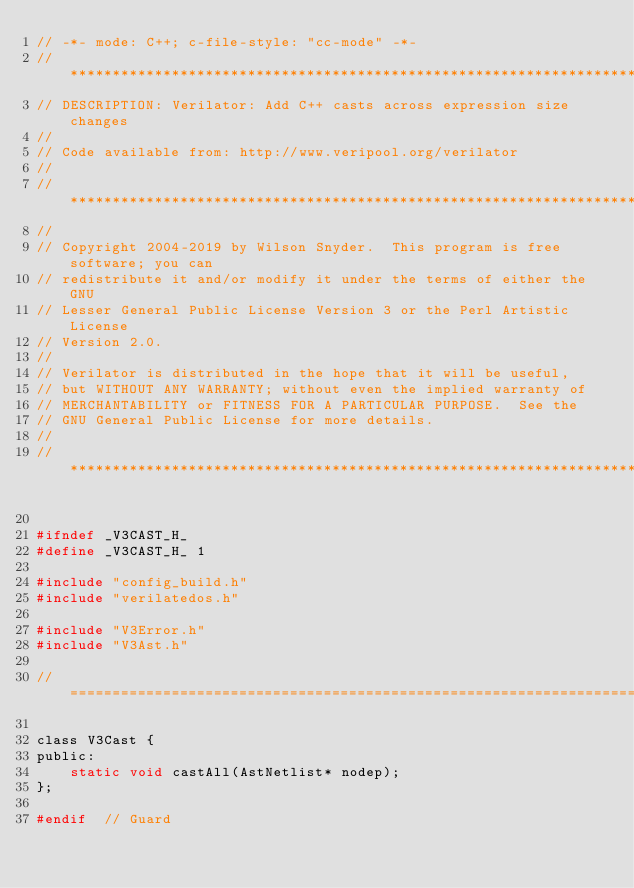Convert code to text. <code><loc_0><loc_0><loc_500><loc_500><_C_>// -*- mode: C++; c-file-style: "cc-mode" -*-
//*************************************************************************
// DESCRIPTION: Verilator: Add C++ casts across expression size changes
//
// Code available from: http://www.veripool.org/verilator
//
//*************************************************************************
//
// Copyright 2004-2019 by Wilson Snyder.  This program is free software; you can
// redistribute it and/or modify it under the terms of either the GNU
// Lesser General Public License Version 3 or the Perl Artistic License
// Version 2.0.
//
// Verilator is distributed in the hope that it will be useful,
// but WITHOUT ANY WARRANTY; without even the implied warranty of
// MERCHANTABILITY or FITNESS FOR A PARTICULAR PURPOSE.  See the
// GNU General Public License for more details.
//
//*************************************************************************

#ifndef _V3CAST_H_
#define _V3CAST_H_ 1

#include "config_build.h"
#include "verilatedos.h"

#include "V3Error.h"
#include "V3Ast.h"

//============================================================================

class V3Cast {
public:
    static void castAll(AstNetlist* nodep);
};

#endif  // Guard
</code> 